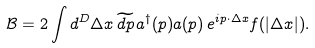Convert formula to latex. <formula><loc_0><loc_0><loc_500><loc_500>\mathcal { B } = 2 \int d ^ { D } \Delta x \, \widetilde { d p } \, a ^ { \dag } ( p ) a ( p ) \, e ^ { i p \cdot \Delta x } f ( | \Delta x | ) .</formula> 